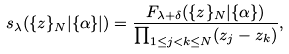Convert formula to latex. <formula><loc_0><loc_0><loc_500><loc_500>s _ { \lambda } ( \{ z \} _ { N } | \{ \alpha \} | ) = \frac { F _ { \lambda + \delta } ( \{ z \} _ { N } | \{ \alpha \} ) } { \prod _ { 1 \leq j < k \leq N } ( z _ { j } - z _ { k } ) } ,</formula> 